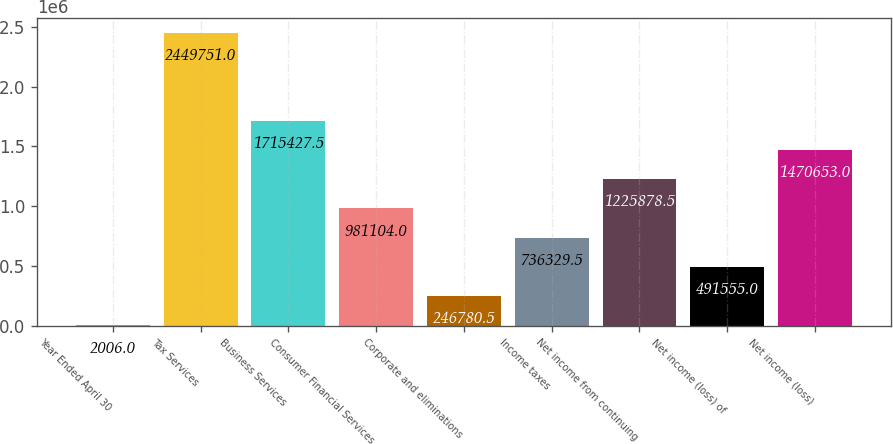Convert chart. <chart><loc_0><loc_0><loc_500><loc_500><bar_chart><fcel>Year Ended April 30<fcel>Tax Services<fcel>Business Services<fcel>Consumer Financial Services<fcel>Corporate and eliminations<fcel>Income taxes<fcel>Net income from continuing<fcel>Net income (loss) of<fcel>Net income (loss)<nl><fcel>2006<fcel>2.44975e+06<fcel>1.71543e+06<fcel>981104<fcel>246780<fcel>736330<fcel>1.22588e+06<fcel>491555<fcel>1.47065e+06<nl></chart> 